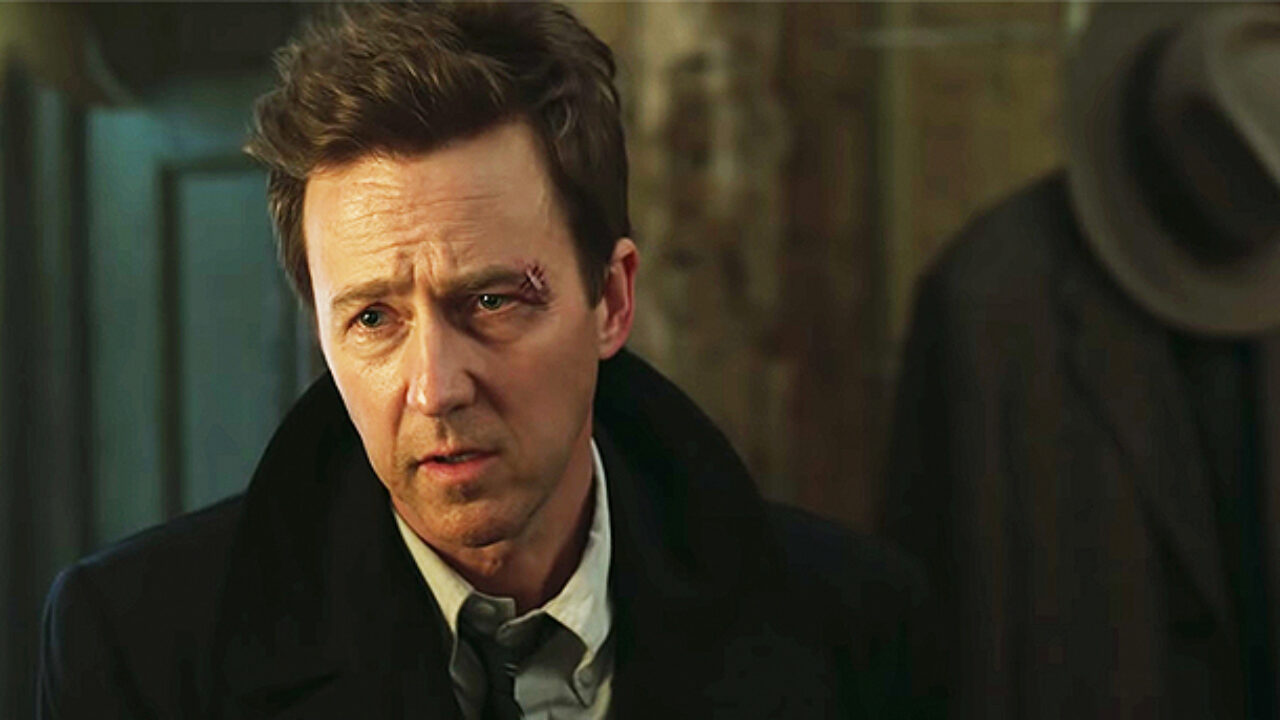What do you think has happened to this character recently? Considering the visible scar near his eye and his solemn expression, it seems like the character might have been involved in a physical altercation. The suit and subdued setting suggest this incident could tie into a larger narrative, possibly one involving danger or betrayal within a professional setting. 